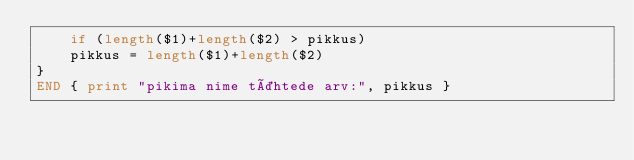Convert code to text. <code><loc_0><loc_0><loc_500><loc_500><_Awk_>    if (length($1)+length($2) > pikkus)
    pikkus = length($1)+length($2)
}
END { print "pikima nime tähtede arv:", pikkus }
</code> 